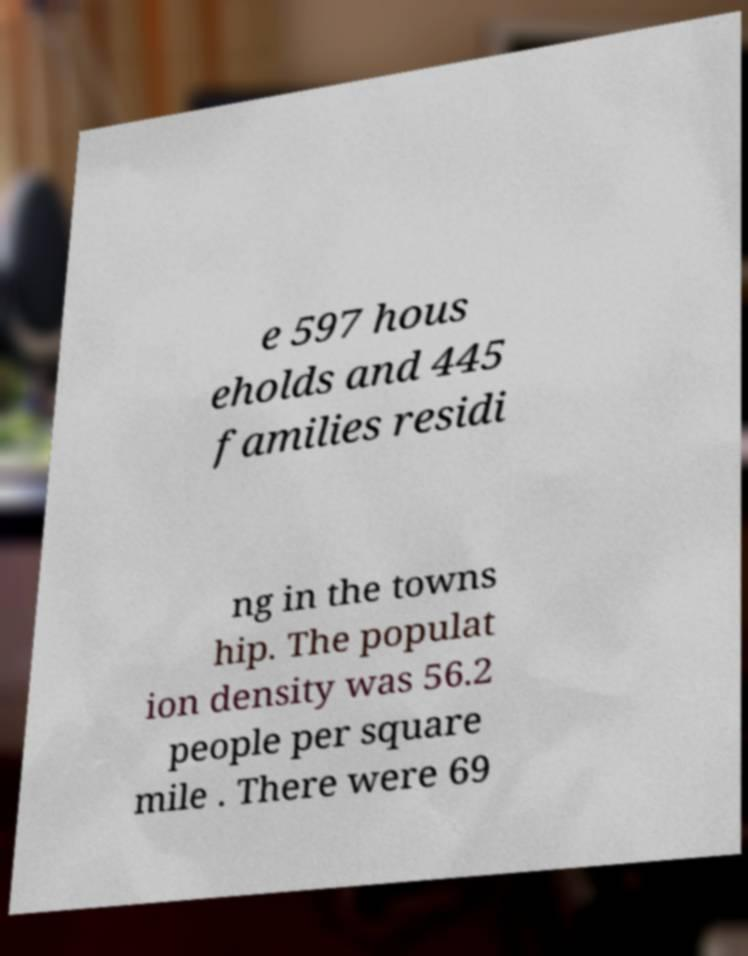What messages or text are displayed in this image? I need them in a readable, typed format. e 597 hous eholds and 445 families residi ng in the towns hip. The populat ion density was 56.2 people per square mile . There were 69 